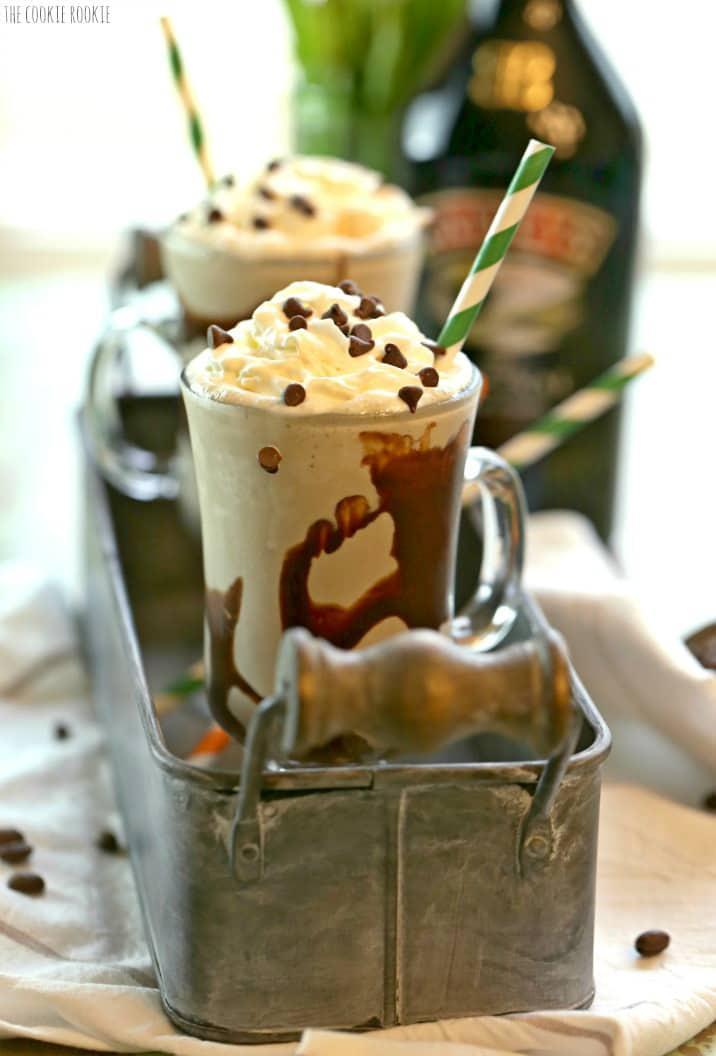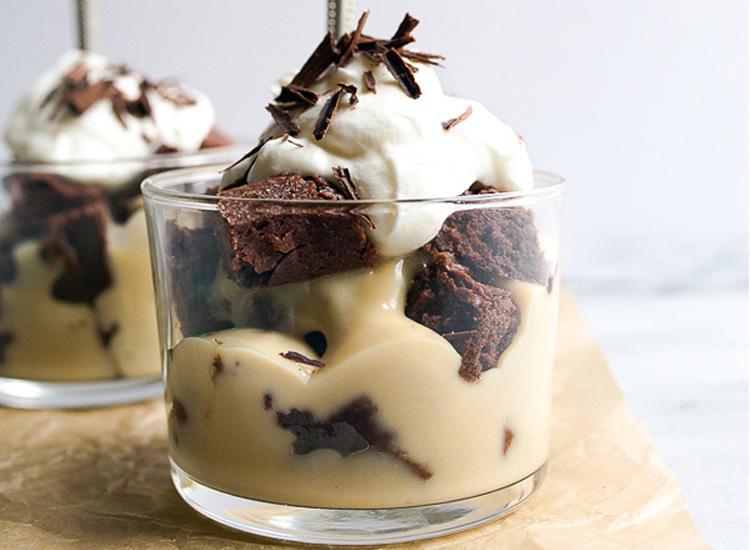The first image is the image on the left, the second image is the image on the right. For the images shown, is this caption "There are two individual servings of desserts in the image on the left." true? Answer yes or no. Yes. 